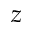Convert formula to latex. <formula><loc_0><loc_0><loc_500><loc_500>z</formula> 